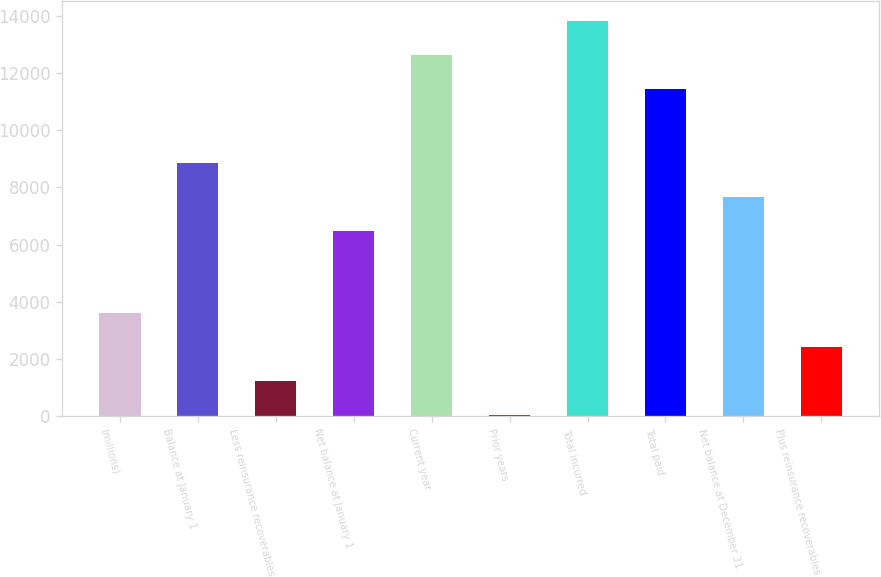Convert chart. <chart><loc_0><loc_0><loc_500><loc_500><bar_chart><fcel>(millions)<fcel>Balance at January 1<fcel>Less reinsurance recoverables<fcel>Net balance at January 1<fcel>Current year<fcel>Prior years<fcel>Total incurred<fcel>Total paid<fcel>Net balance at December 31<fcel>Plus reinsurance recoverables<nl><fcel>3599.8<fcel>8845.3<fcel>1214.6<fcel>6460.1<fcel>12624.4<fcel>22<fcel>13817<fcel>11431.8<fcel>7652.7<fcel>2407.2<nl></chart> 